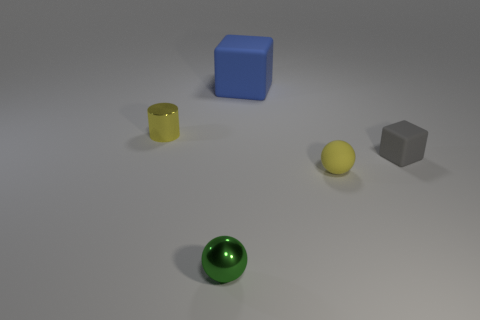Add 2 metallic balls. How many objects exist? 7 Subtract all cylinders. How many objects are left? 4 Add 1 small things. How many small things are left? 5 Add 5 large green metallic cylinders. How many large green metallic cylinders exist? 5 Subtract 1 yellow spheres. How many objects are left? 4 Subtract all big brown matte cubes. Subtract all tiny green spheres. How many objects are left? 4 